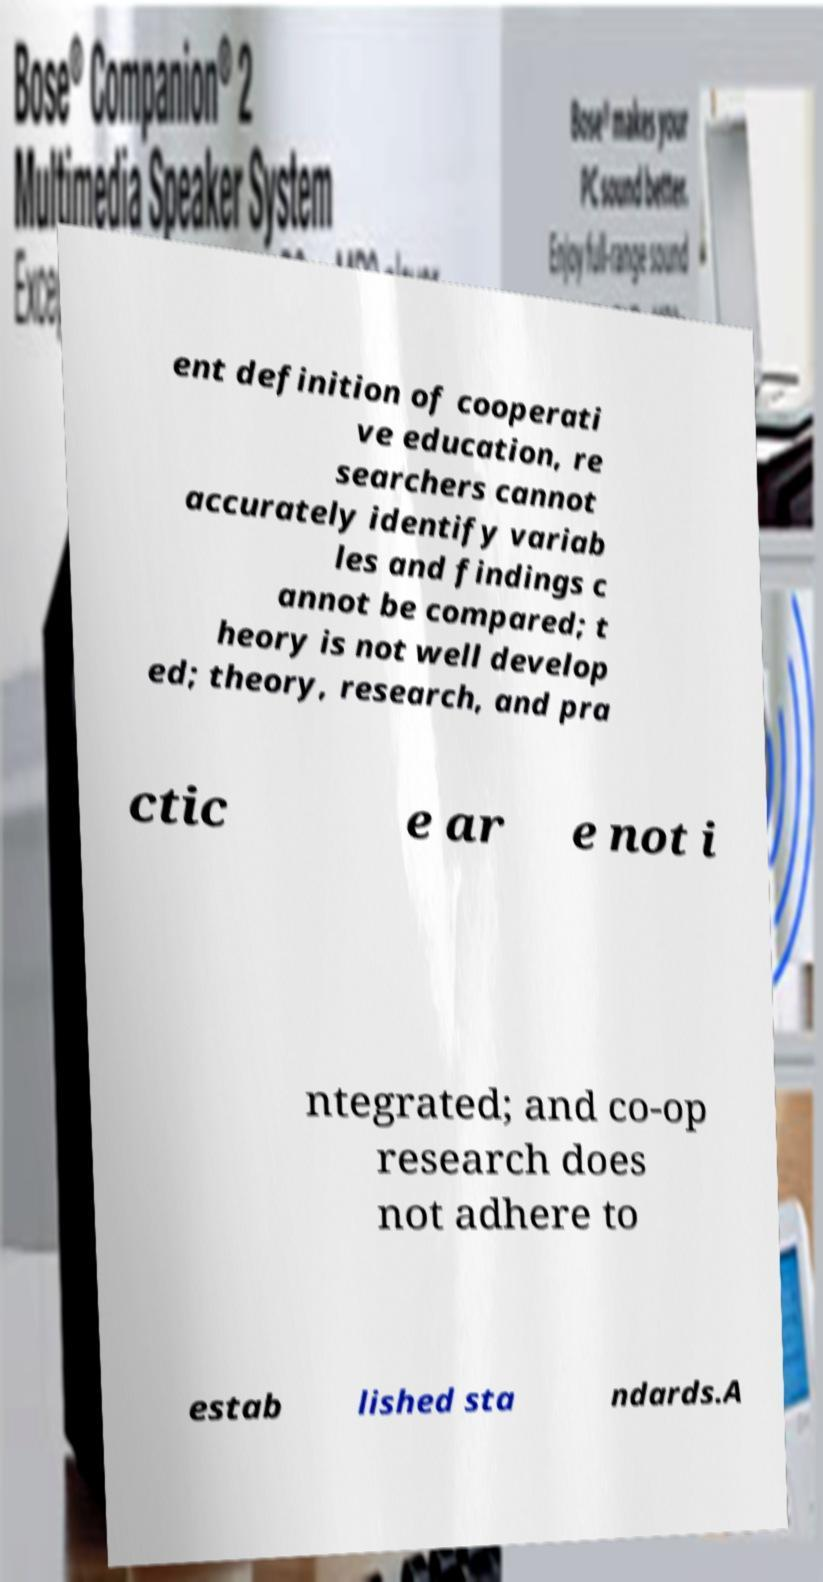Can you read and provide the text displayed in the image?This photo seems to have some interesting text. Can you extract and type it out for me? ent definition of cooperati ve education, re searchers cannot accurately identify variab les and findings c annot be compared; t heory is not well develop ed; theory, research, and pra ctic e ar e not i ntegrated; and co-op research does not adhere to estab lished sta ndards.A 